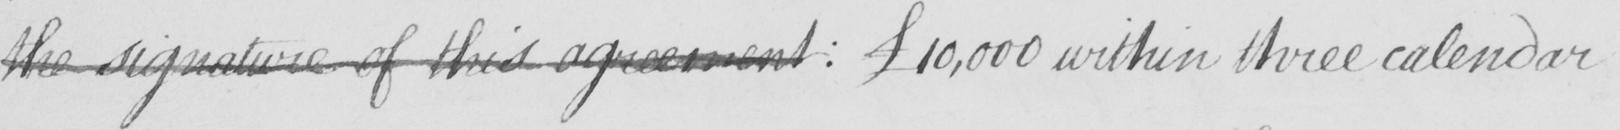Can you read and transcribe this handwriting? the signature of this agreement :  £10,000 within three calendar 